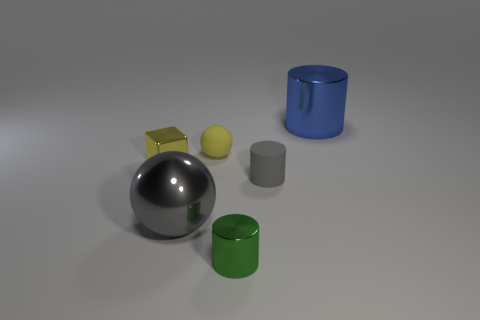Subtract all shiny cylinders. How many cylinders are left? 1 Add 1 gray metal balls. How many objects exist? 7 Subtract all gray cylinders. How many cylinders are left? 2 Subtract 1 spheres. How many spheres are left? 1 Subtract all blue blocks. How many blue cylinders are left? 1 Add 4 small yellow metallic things. How many small yellow metallic things exist? 5 Subtract 0 red blocks. How many objects are left? 6 Subtract all balls. How many objects are left? 4 Subtract all blue cubes. Subtract all gray cylinders. How many cubes are left? 1 Subtract all tiny yellow shiny things. Subtract all large things. How many objects are left? 3 